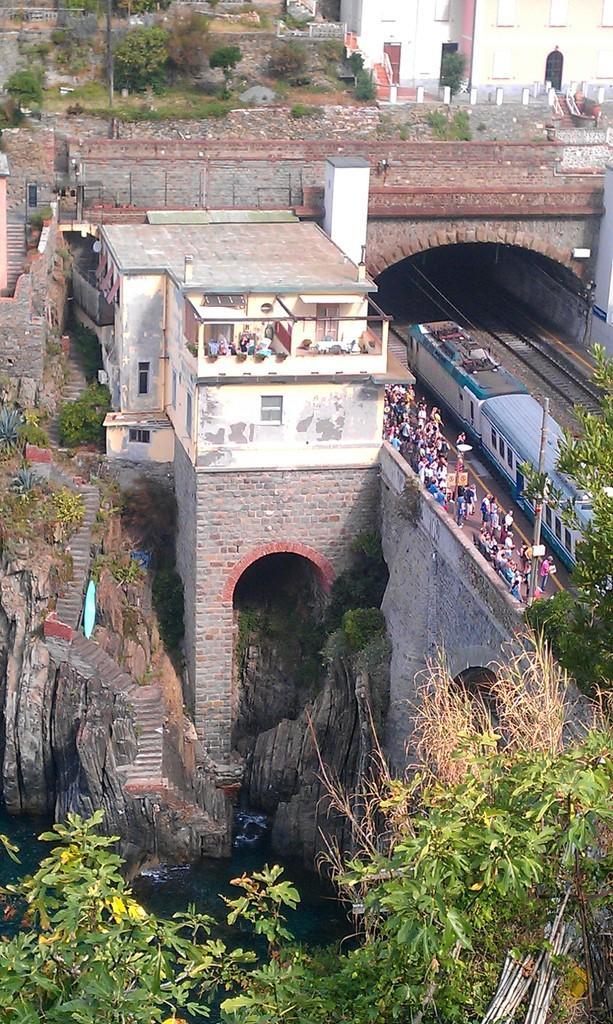In one or two sentences, can you explain what this image depicts? In this picture we can see a train on the tracks, beside to the train we can find few people and trees, and also we can see water and few buildings. 